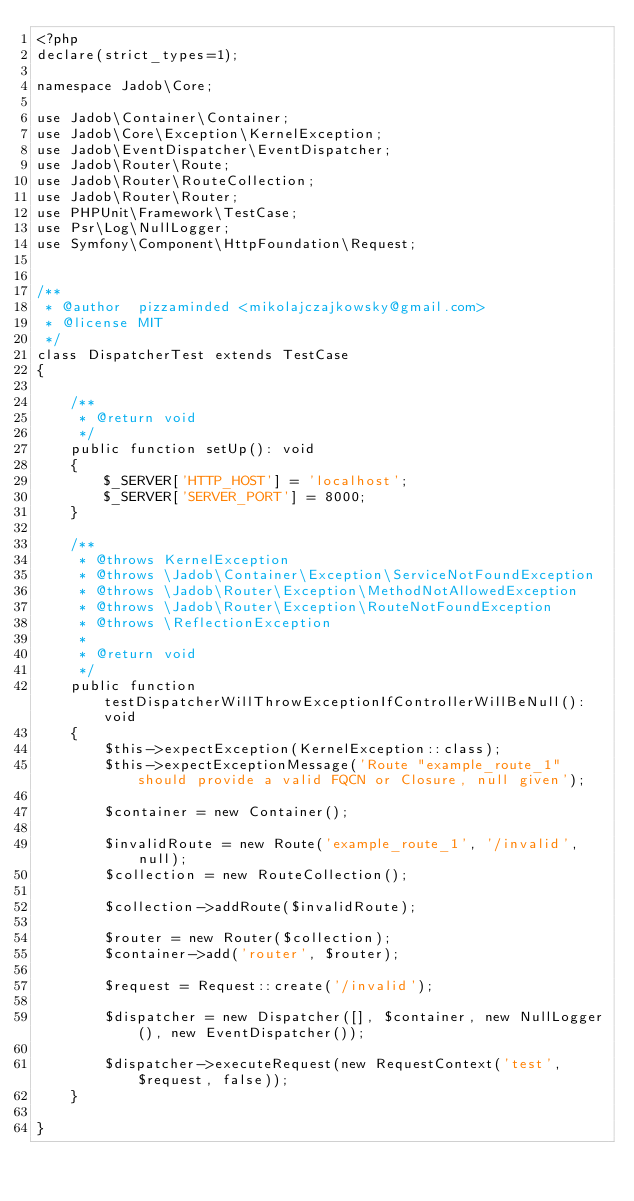Convert code to text. <code><loc_0><loc_0><loc_500><loc_500><_PHP_><?php
declare(strict_types=1);

namespace Jadob\Core;

use Jadob\Container\Container;
use Jadob\Core\Exception\KernelException;
use Jadob\EventDispatcher\EventDispatcher;
use Jadob\Router\Route;
use Jadob\Router\RouteCollection;
use Jadob\Router\Router;
use PHPUnit\Framework\TestCase;
use Psr\Log\NullLogger;
use Symfony\Component\HttpFoundation\Request;


/**
 * @author  pizzaminded <mikolajczajkowsky@gmail.com>
 * @license MIT
 */
class DispatcherTest extends TestCase
{

    /**
     * @return void
     */
    public function setUp(): void
    {
        $_SERVER['HTTP_HOST'] = 'localhost';
        $_SERVER['SERVER_PORT'] = 8000;
    }

    /**
     * @throws KernelException
     * @throws \Jadob\Container\Exception\ServiceNotFoundException
     * @throws \Jadob\Router\Exception\MethodNotAllowedException
     * @throws \Jadob\Router\Exception\RouteNotFoundException
     * @throws \ReflectionException
     *
     * @return void
     */
    public function testDispatcherWillThrowExceptionIfControllerWillBeNull(): void
    {
        $this->expectException(KernelException::class);
        $this->expectExceptionMessage('Route "example_route_1" should provide a valid FQCN or Closure, null given');

        $container = new Container();

        $invalidRoute = new Route('example_route_1', '/invalid', null);
        $collection = new RouteCollection();

        $collection->addRoute($invalidRoute);

        $router = new Router($collection);
        $container->add('router', $router);

        $request = Request::create('/invalid');

        $dispatcher = new Dispatcher([], $container, new NullLogger(), new EventDispatcher());

        $dispatcher->executeRequest(new RequestContext('test', $request, false));
    }

}</code> 